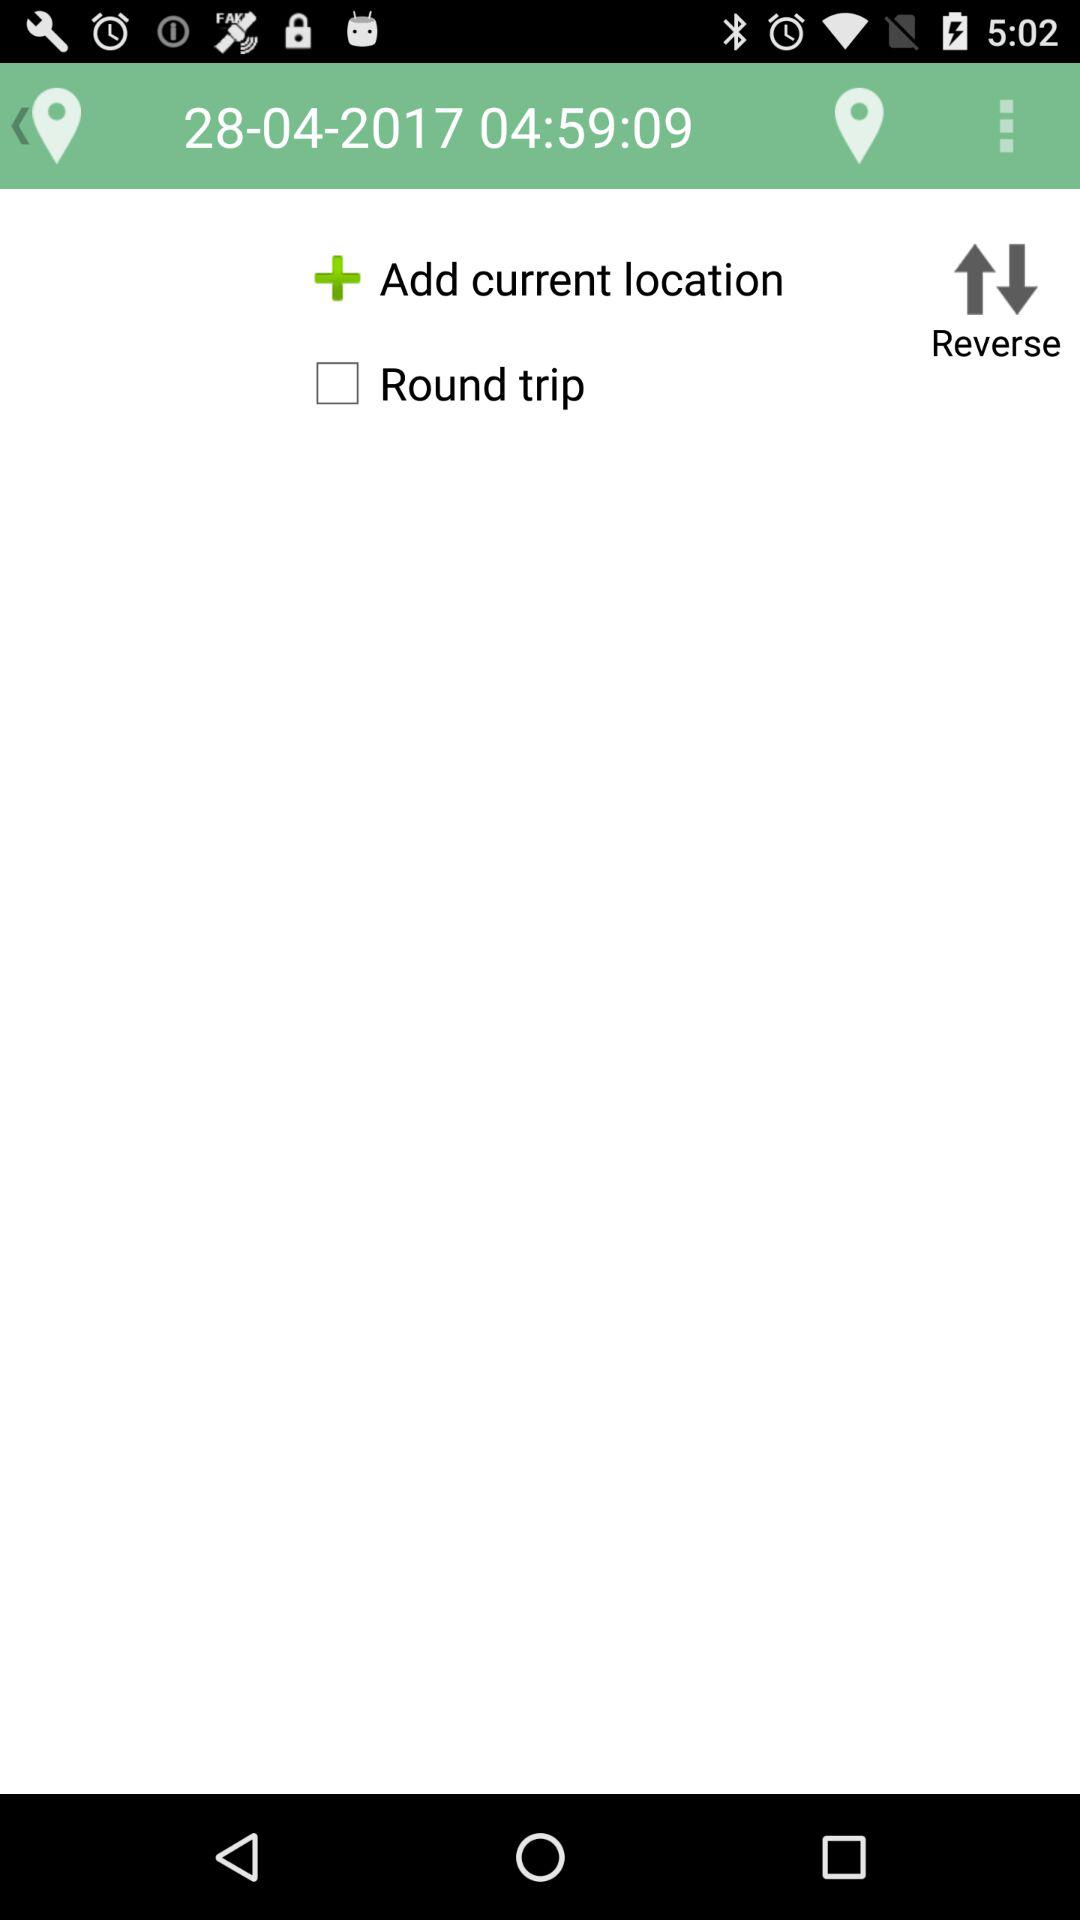What's the status of "Round trip"? The status is "off". 